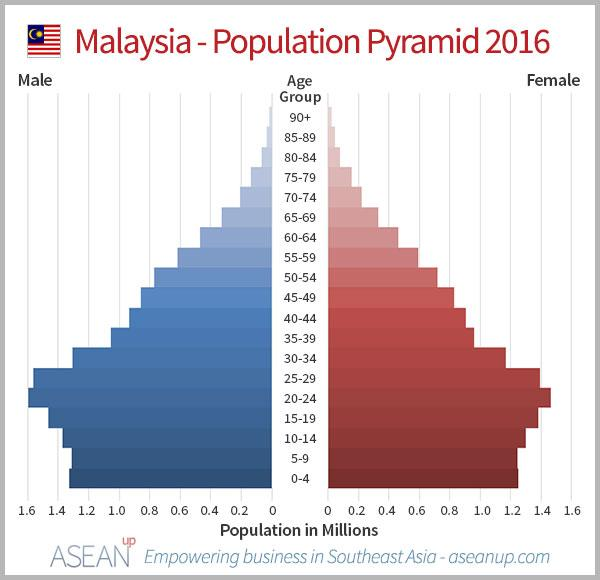Mention a couple of crucial points in this snapshot. There are 19 age groups mentioned in this infographic. 